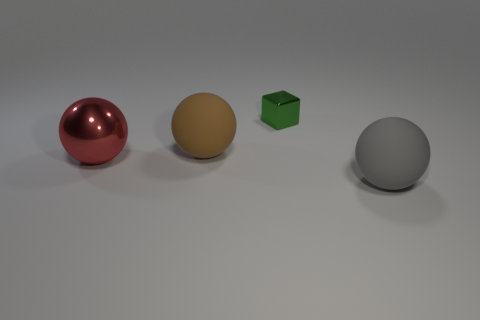Add 3 metallic cubes. How many objects exist? 7 Subtract all cubes. How many objects are left? 3 Subtract all big brown rubber objects. Subtract all gray rubber balls. How many objects are left? 2 Add 1 green things. How many green things are left? 2 Add 3 metallic things. How many metallic things exist? 5 Subtract 0 brown cylinders. How many objects are left? 4 